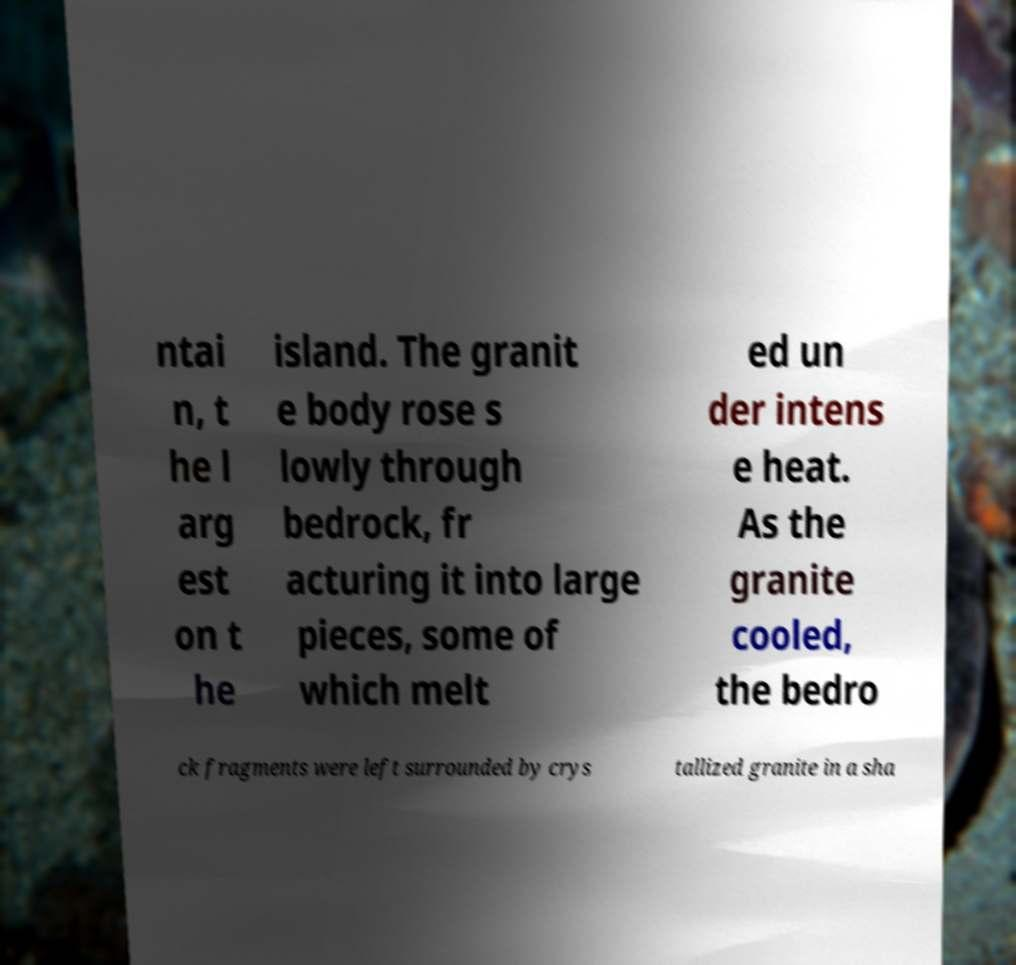Can you read and provide the text displayed in the image?This photo seems to have some interesting text. Can you extract and type it out for me? ntai n, t he l arg est on t he island. The granit e body rose s lowly through bedrock, fr acturing it into large pieces, some of which melt ed un der intens e heat. As the granite cooled, the bedro ck fragments were left surrounded by crys tallized granite in a sha 